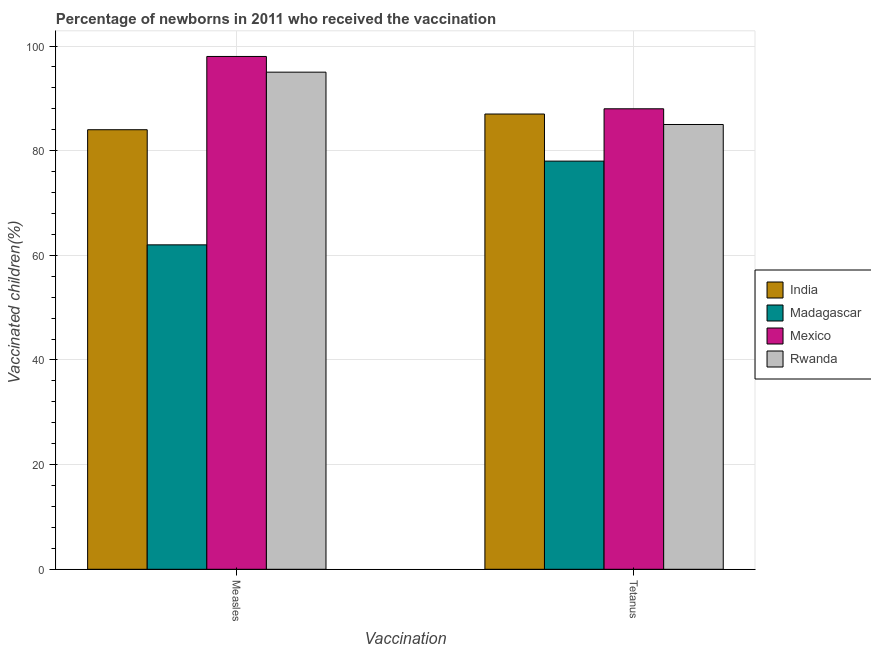How many different coloured bars are there?
Your response must be concise. 4. How many groups of bars are there?
Your answer should be compact. 2. Are the number of bars on each tick of the X-axis equal?
Ensure brevity in your answer.  Yes. How many bars are there on the 1st tick from the left?
Ensure brevity in your answer.  4. What is the label of the 1st group of bars from the left?
Your answer should be very brief. Measles. What is the percentage of newborns who received vaccination for tetanus in Madagascar?
Offer a very short reply. 78. Across all countries, what is the maximum percentage of newborns who received vaccination for measles?
Offer a very short reply. 98. Across all countries, what is the minimum percentage of newborns who received vaccination for measles?
Offer a terse response. 62. In which country was the percentage of newborns who received vaccination for tetanus maximum?
Your answer should be compact. Mexico. In which country was the percentage of newborns who received vaccination for measles minimum?
Offer a very short reply. Madagascar. What is the total percentage of newborns who received vaccination for measles in the graph?
Offer a terse response. 339. What is the difference between the percentage of newborns who received vaccination for measles in Madagascar and that in India?
Provide a succinct answer. -22. What is the difference between the percentage of newborns who received vaccination for tetanus in India and the percentage of newborns who received vaccination for measles in Madagascar?
Make the answer very short. 25. What is the average percentage of newborns who received vaccination for measles per country?
Offer a very short reply. 84.75. What is the difference between the percentage of newborns who received vaccination for measles and percentage of newborns who received vaccination for tetanus in Rwanda?
Provide a succinct answer. 10. What is the ratio of the percentage of newborns who received vaccination for measles in Rwanda to that in Madagascar?
Provide a short and direct response. 1.53. Is the percentage of newborns who received vaccination for measles in Mexico less than that in India?
Offer a very short reply. No. In how many countries, is the percentage of newborns who received vaccination for tetanus greater than the average percentage of newborns who received vaccination for tetanus taken over all countries?
Your response must be concise. 3. Are all the bars in the graph horizontal?
Your answer should be compact. No. How many countries are there in the graph?
Offer a very short reply. 4. Are the values on the major ticks of Y-axis written in scientific E-notation?
Provide a short and direct response. No. How many legend labels are there?
Keep it short and to the point. 4. What is the title of the graph?
Ensure brevity in your answer.  Percentage of newborns in 2011 who received the vaccination. What is the label or title of the X-axis?
Your response must be concise. Vaccination. What is the label or title of the Y-axis?
Your response must be concise. Vaccinated children(%)
. What is the Vaccinated children(%)
 in India in Measles?
Offer a terse response. 84. What is the Vaccinated children(%)
 in Madagascar in Measles?
Make the answer very short. 62. What is the Vaccinated children(%)
 of Rwanda in Measles?
Your response must be concise. 95. What is the Vaccinated children(%)
 in India in Tetanus?
Your answer should be very brief. 87. What is the Vaccinated children(%)
 of Madagascar in Tetanus?
Your answer should be very brief. 78. What is the Vaccinated children(%)
 of Mexico in Tetanus?
Provide a short and direct response. 88. Across all Vaccination, what is the maximum Vaccinated children(%)
 in India?
Give a very brief answer. 87. Across all Vaccination, what is the maximum Vaccinated children(%)
 in Mexico?
Your answer should be very brief. 98. Across all Vaccination, what is the minimum Vaccinated children(%)
 of India?
Your response must be concise. 84. Across all Vaccination, what is the minimum Vaccinated children(%)
 in Madagascar?
Offer a very short reply. 62. Across all Vaccination, what is the minimum Vaccinated children(%)
 in Mexico?
Offer a terse response. 88. Across all Vaccination, what is the minimum Vaccinated children(%)
 in Rwanda?
Make the answer very short. 85. What is the total Vaccinated children(%)
 of India in the graph?
Provide a short and direct response. 171. What is the total Vaccinated children(%)
 of Madagascar in the graph?
Keep it short and to the point. 140. What is the total Vaccinated children(%)
 of Mexico in the graph?
Offer a very short reply. 186. What is the total Vaccinated children(%)
 in Rwanda in the graph?
Provide a succinct answer. 180. What is the difference between the Vaccinated children(%)
 in India in Measles and that in Tetanus?
Your response must be concise. -3. What is the difference between the Vaccinated children(%)
 in India in Measles and the Vaccinated children(%)
 in Madagascar in Tetanus?
Provide a succinct answer. 6. What is the difference between the Vaccinated children(%)
 of Mexico in Measles and the Vaccinated children(%)
 of Rwanda in Tetanus?
Offer a very short reply. 13. What is the average Vaccinated children(%)
 of India per Vaccination?
Keep it short and to the point. 85.5. What is the average Vaccinated children(%)
 of Madagascar per Vaccination?
Your answer should be very brief. 70. What is the average Vaccinated children(%)
 in Mexico per Vaccination?
Provide a succinct answer. 93. What is the difference between the Vaccinated children(%)
 in India and Vaccinated children(%)
 in Madagascar in Measles?
Your answer should be compact. 22. What is the difference between the Vaccinated children(%)
 of India and Vaccinated children(%)
 of Mexico in Measles?
Your answer should be very brief. -14. What is the difference between the Vaccinated children(%)
 of India and Vaccinated children(%)
 of Rwanda in Measles?
Give a very brief answer. -11. What is the difference between the Vaccinated children(%)
 in Madagascar and Vaccinated children(%)
 in Mexico in Measles?
Give a very brief answer. -36. What is the difference between the Vaccinated children(%)
 in Madagascar and Vaccinated children(%)
 in Rwanda in Measles?
Your answer should be compact. -33. What is the difference between the Vaccinated children(%)
 in Mexico and Vaccinated children(%)
 in Rwanda in Measles?
Offer a very short reply. 3. What is the difference between the Vaccinated children(%)
 in India and Vaccinated children(%)
 in Madagascar in Tetanus?
Your answer should be very brief. 9. What is the difference between the Vaccinated children(%)
 in India and Vaccinated children(%)
 in Mexico in Tetanus?
Your answer should be compact. -1. What is the difference between the Vaccinated children(%)
 in Madagascar and Vaccinated children(%)
 in Mexico in Tetanus?
Your answer should be very brief. -10. What is the difference between the Vaccinated children(%)
 of Madagascar and Vaccinated children(%)
 of Rwanda in Tetanus?
Your answer should be very brief. -7. What is the difference between the Vaccinated children(%)
 of Mexico and Vaccinated children(%)
 of Rwanda in Tetanus?
Give a very brief answer. 3. What is the ratio of the Vaccinated children(%)
 of India in Measles to that in Tetanus?
Give a very brief answer. 0.97. What is the ratio of the Vaccinated children(%)
 in Madagascar in Measles to that in Tetanus?
Your answer should be compact. 0.79. What is the ratio of the Vaccinated children(%)
 of Mexico in Measles to that in Tetanus?
Provide a succinct answer. 1.11. What is the ratio of the Vaccinated children(%)
 of Rwanda in Measles to that in Tetanus?
Offer a very short reply. 1.12. What is the difference between the highest and the lowest Vaccinated children(%)
 in Madagascar?
Your answer should be compact. 16. What is the difference between the highest and the lowest Vaccinated children(%)
 of Mexico?
Offer a very short reply. 10. 